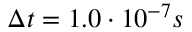<formula> <loc_0><loc_0><loc_500><loc_500>\Delta t = 1 . 0 \cdot 1 0 ^ { - 7 } s</formula> 